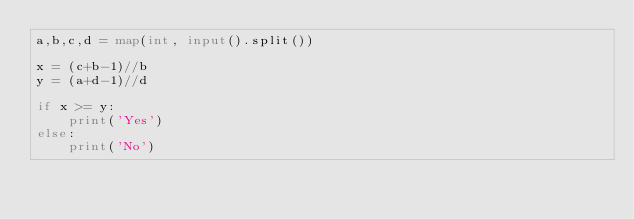<code> <loc_0><loc_0><loc_500><loc_500><_Python_>a,b,c,d = map(int, input().split())

x = (c+b-1)//b
y = (a+d-1)//d

if x >= y:
    print('Yes')
else:
    print('No')</code> 